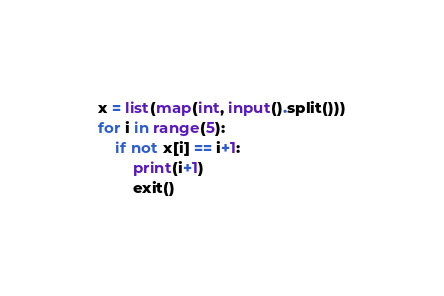Convert code to text. <code><loc_0><loc_0><loc_500><loc_500><_Python_>x = list(map(int, input().split()))
for i in range(5):
    if not x[i] == i+1:
        print(i+1)
        exit()
</code> 